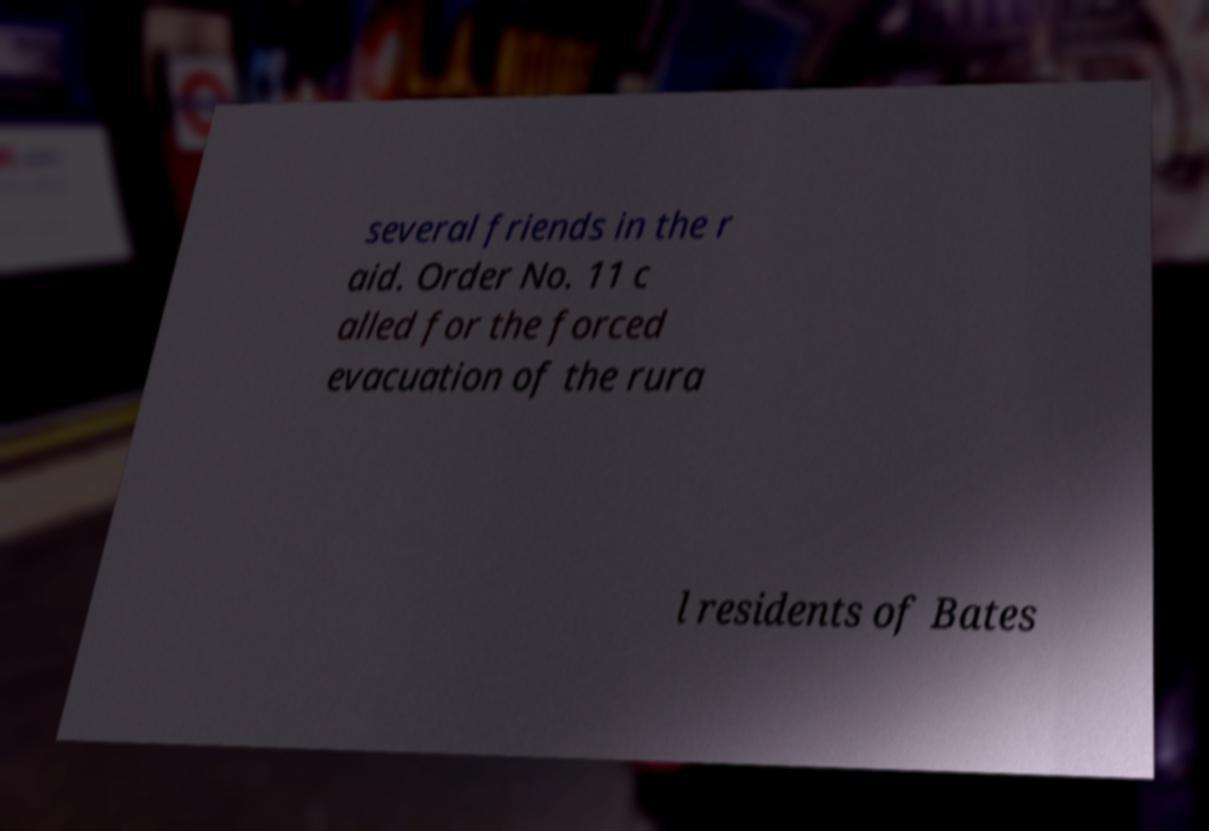There's text embedded in this image that I need extracted. Can you transcribe it verbatim? several friends in the r aid. Order No. 11 c alled for the forced evacuation of the rura l residents of Bates 